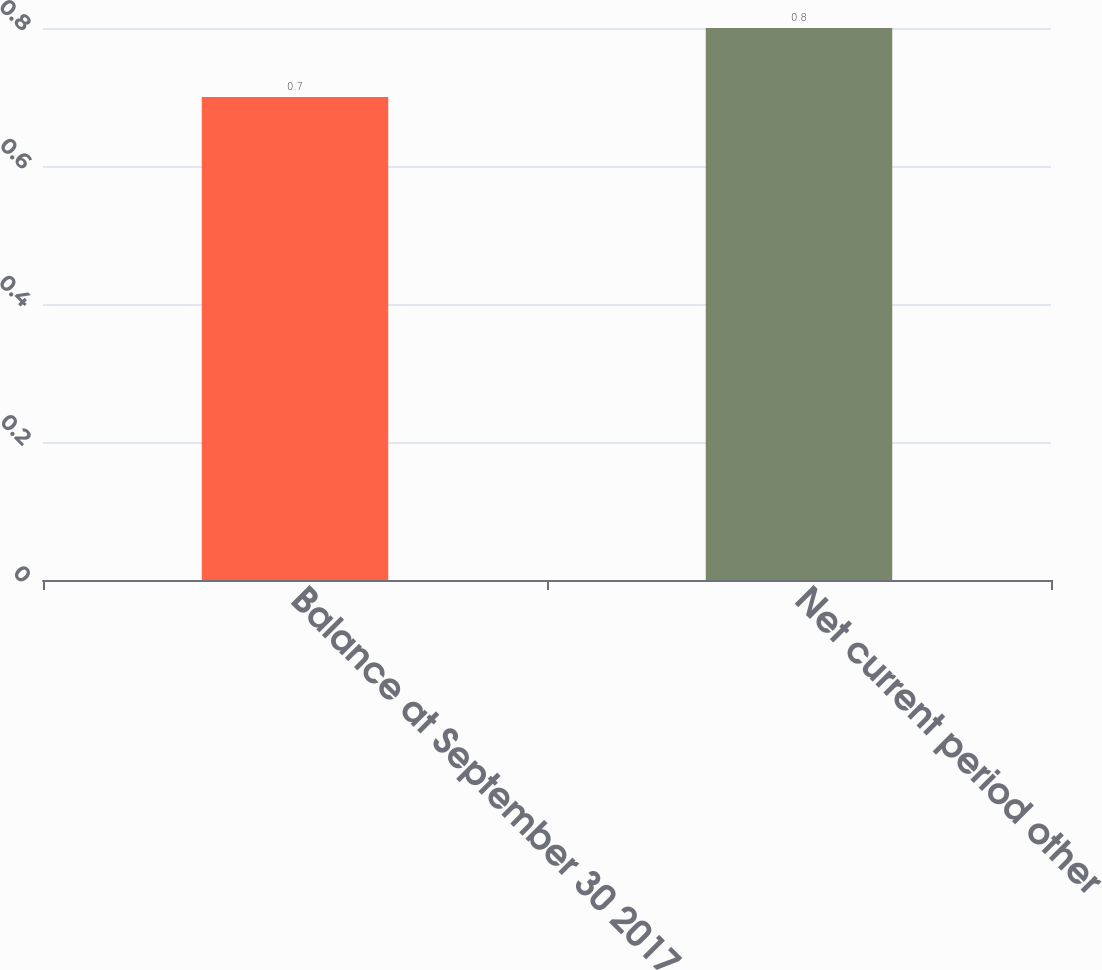Convert chart. <chart><loc_0><loc_0><loc_500><loc_500><bar_chart><fcel>Balance at September 30 2017<fcel>Net current period other<nl><fcel>0.7<fcel>0.8<nl></chart> 